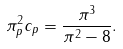Convert formula to latex. <formula><loc_0><loc_0><loc_500><loc_500>\pi _ { p } ^ { 2 } c _ { p } = \frac { \pi ^ { 3 } } { \pi ^ { 2 } - 8 } .</formula> 